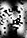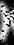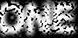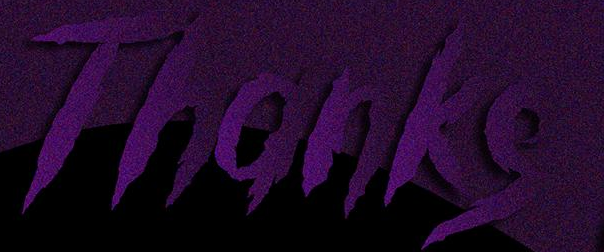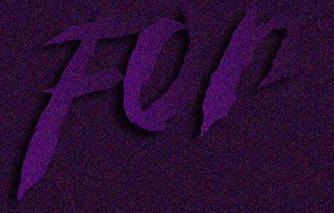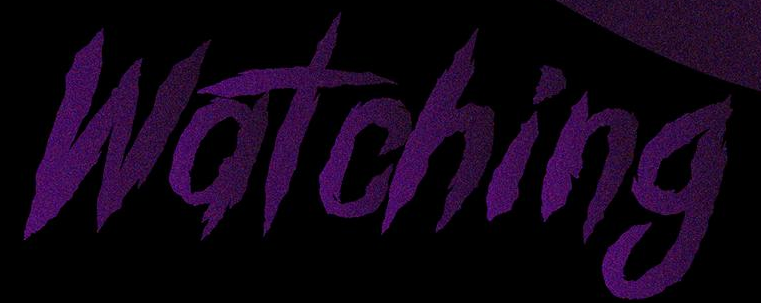Read the text from these images in sequence, separated by a semicolon. N; ); ONE; Thanks; For; Watching 